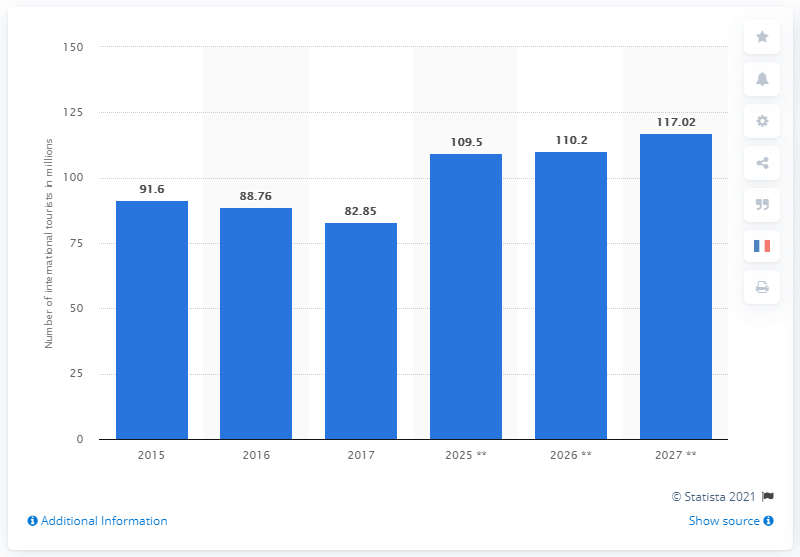Indicate a few pertinent items in this graphic. It is projected that 110.2 international tourists will travel to France in 2025. 